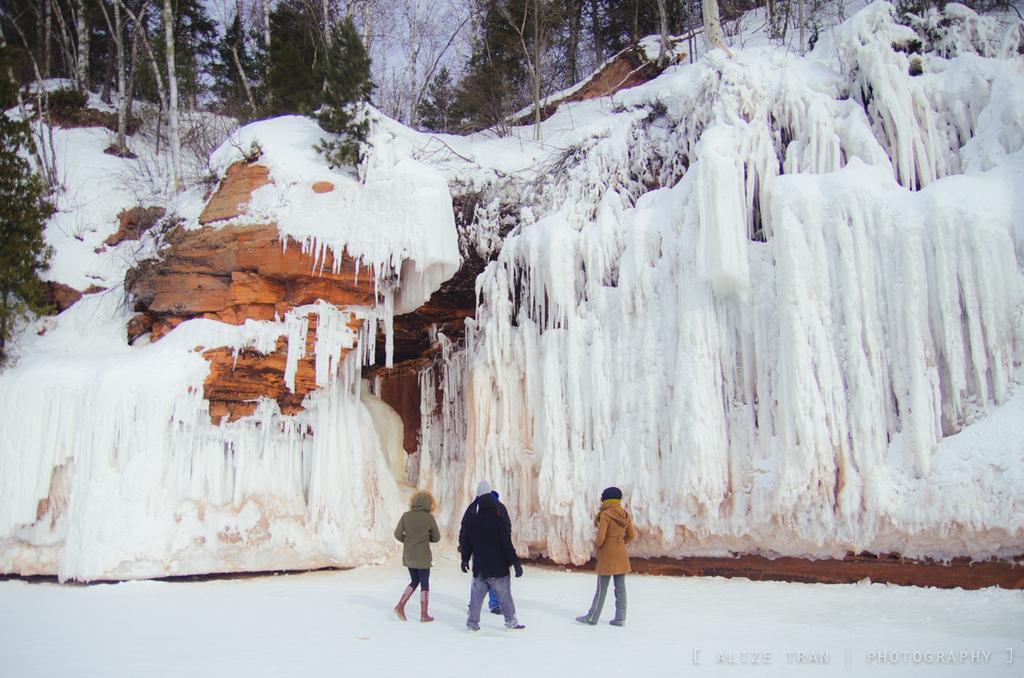How would you summarize this image in a sentence or two? In this image we can see a group of people standing on snow. In the background, we can see mountains and a group of trees. 